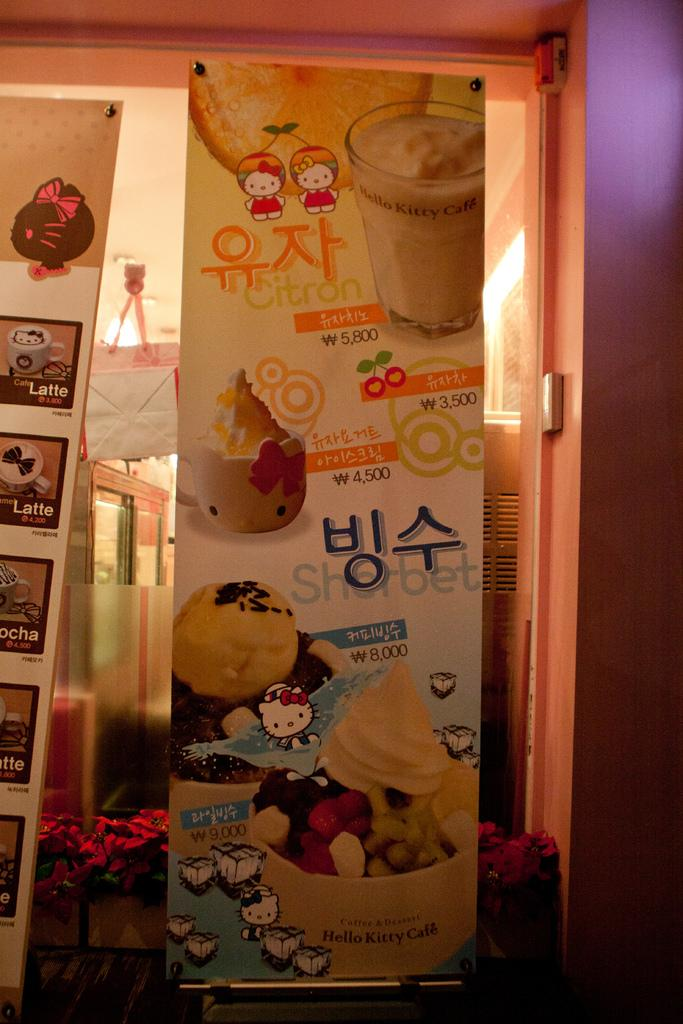What decorative items can be seen in the image? There are banners in the image. What natural elements are present in the image? There are flowers visible in the image. What material is used for the object that shows the bag and furniture? There is glass in the image, which allows us to see the bag and furniture. What type of objects can be seen through the glass? Furniture is visible through the glass. How many flies can be seen on the banners in the image? There are no flies present in the image; it only features banners, flowers, glass, a bag, and furniture. 